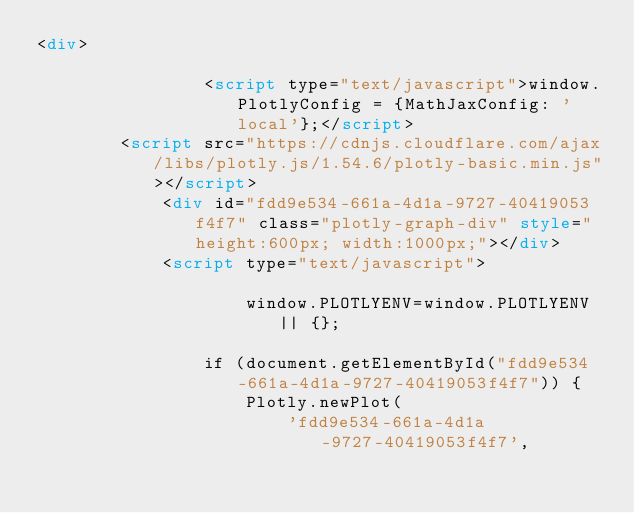<code> <loc_0><loc_0><loc_500><loc_500><_HTML_><div>
        
                <script type="text/javascript">window.PlotlyConfig = {MathJaxConfig: 'local'};</script>
        <script src="https://cdnjs.cloudflare.com/ajax/libs/plotly.js/1.54.6/plotly-basic.min.js"></script>    
            <div id="fdd9e534-661a-4d1a-9727-40419053f4f7" class="plotly-graph-div" style="height:600px; width:1000px;"></div>
            <script type="text/javascript">
                
                    window.PLOTLYENV=window.PLOTLYENV || {};
                    
                if (document.getElementById("fdd9e534-661a-4d1a-9727-40419053f4f7")) {
                    Plotly.newPlot(
                        'fdd9e534-661a-4d1a-9727-40419053f4f7',</code> 